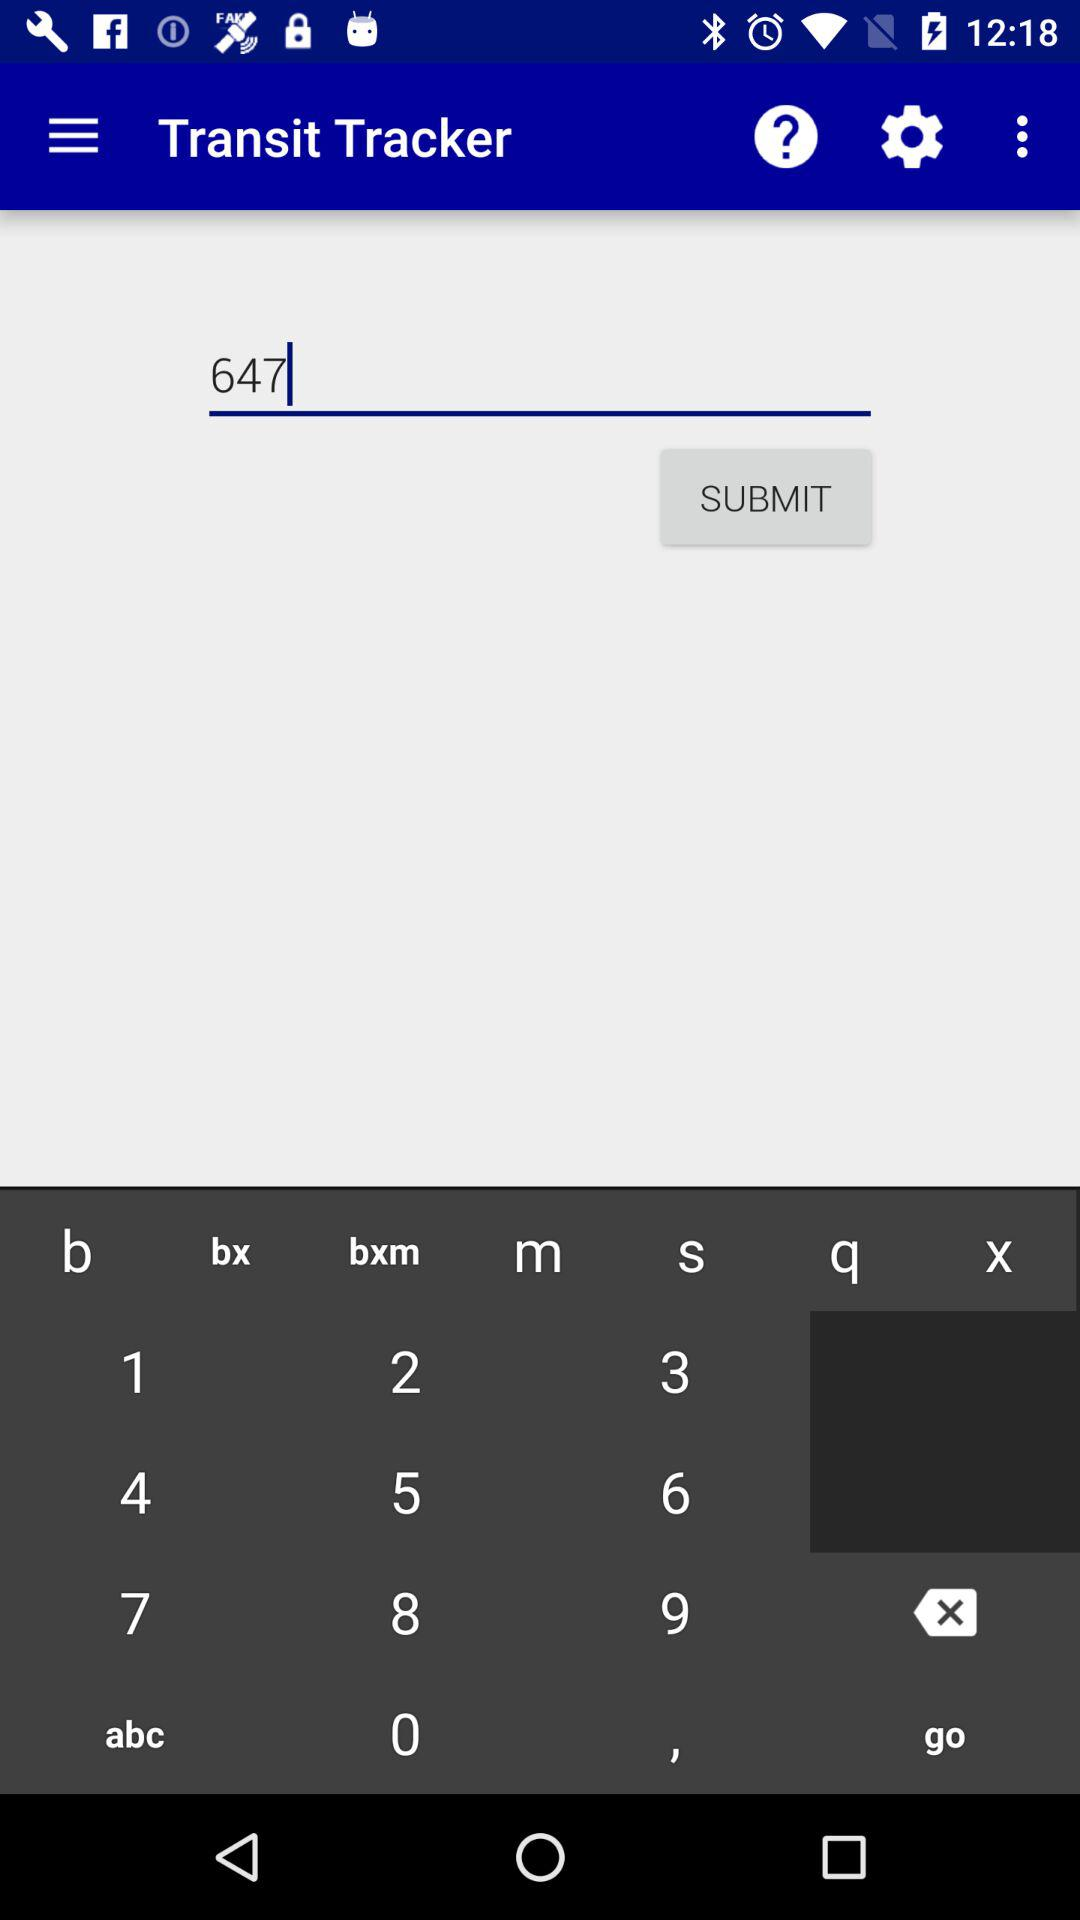What's the number? The number is 647. 